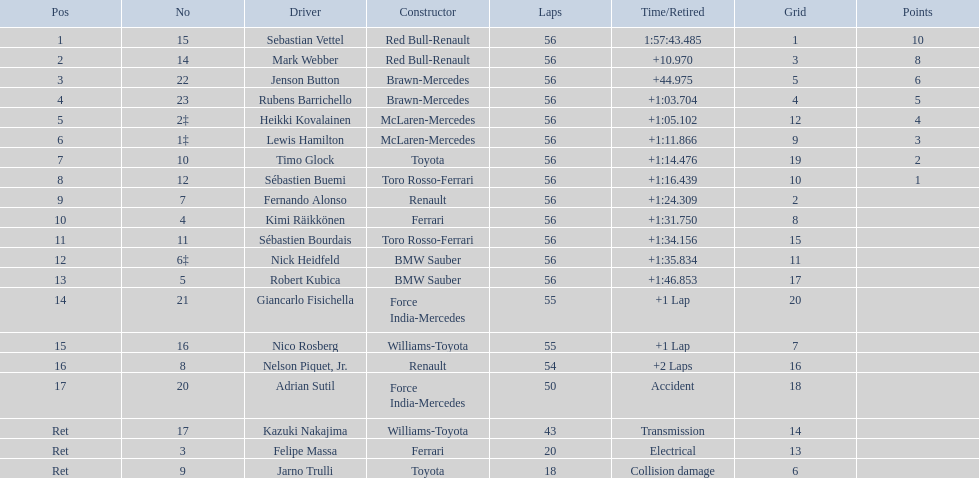Who was at the bottom of the driver list? Jarno Trulli. 